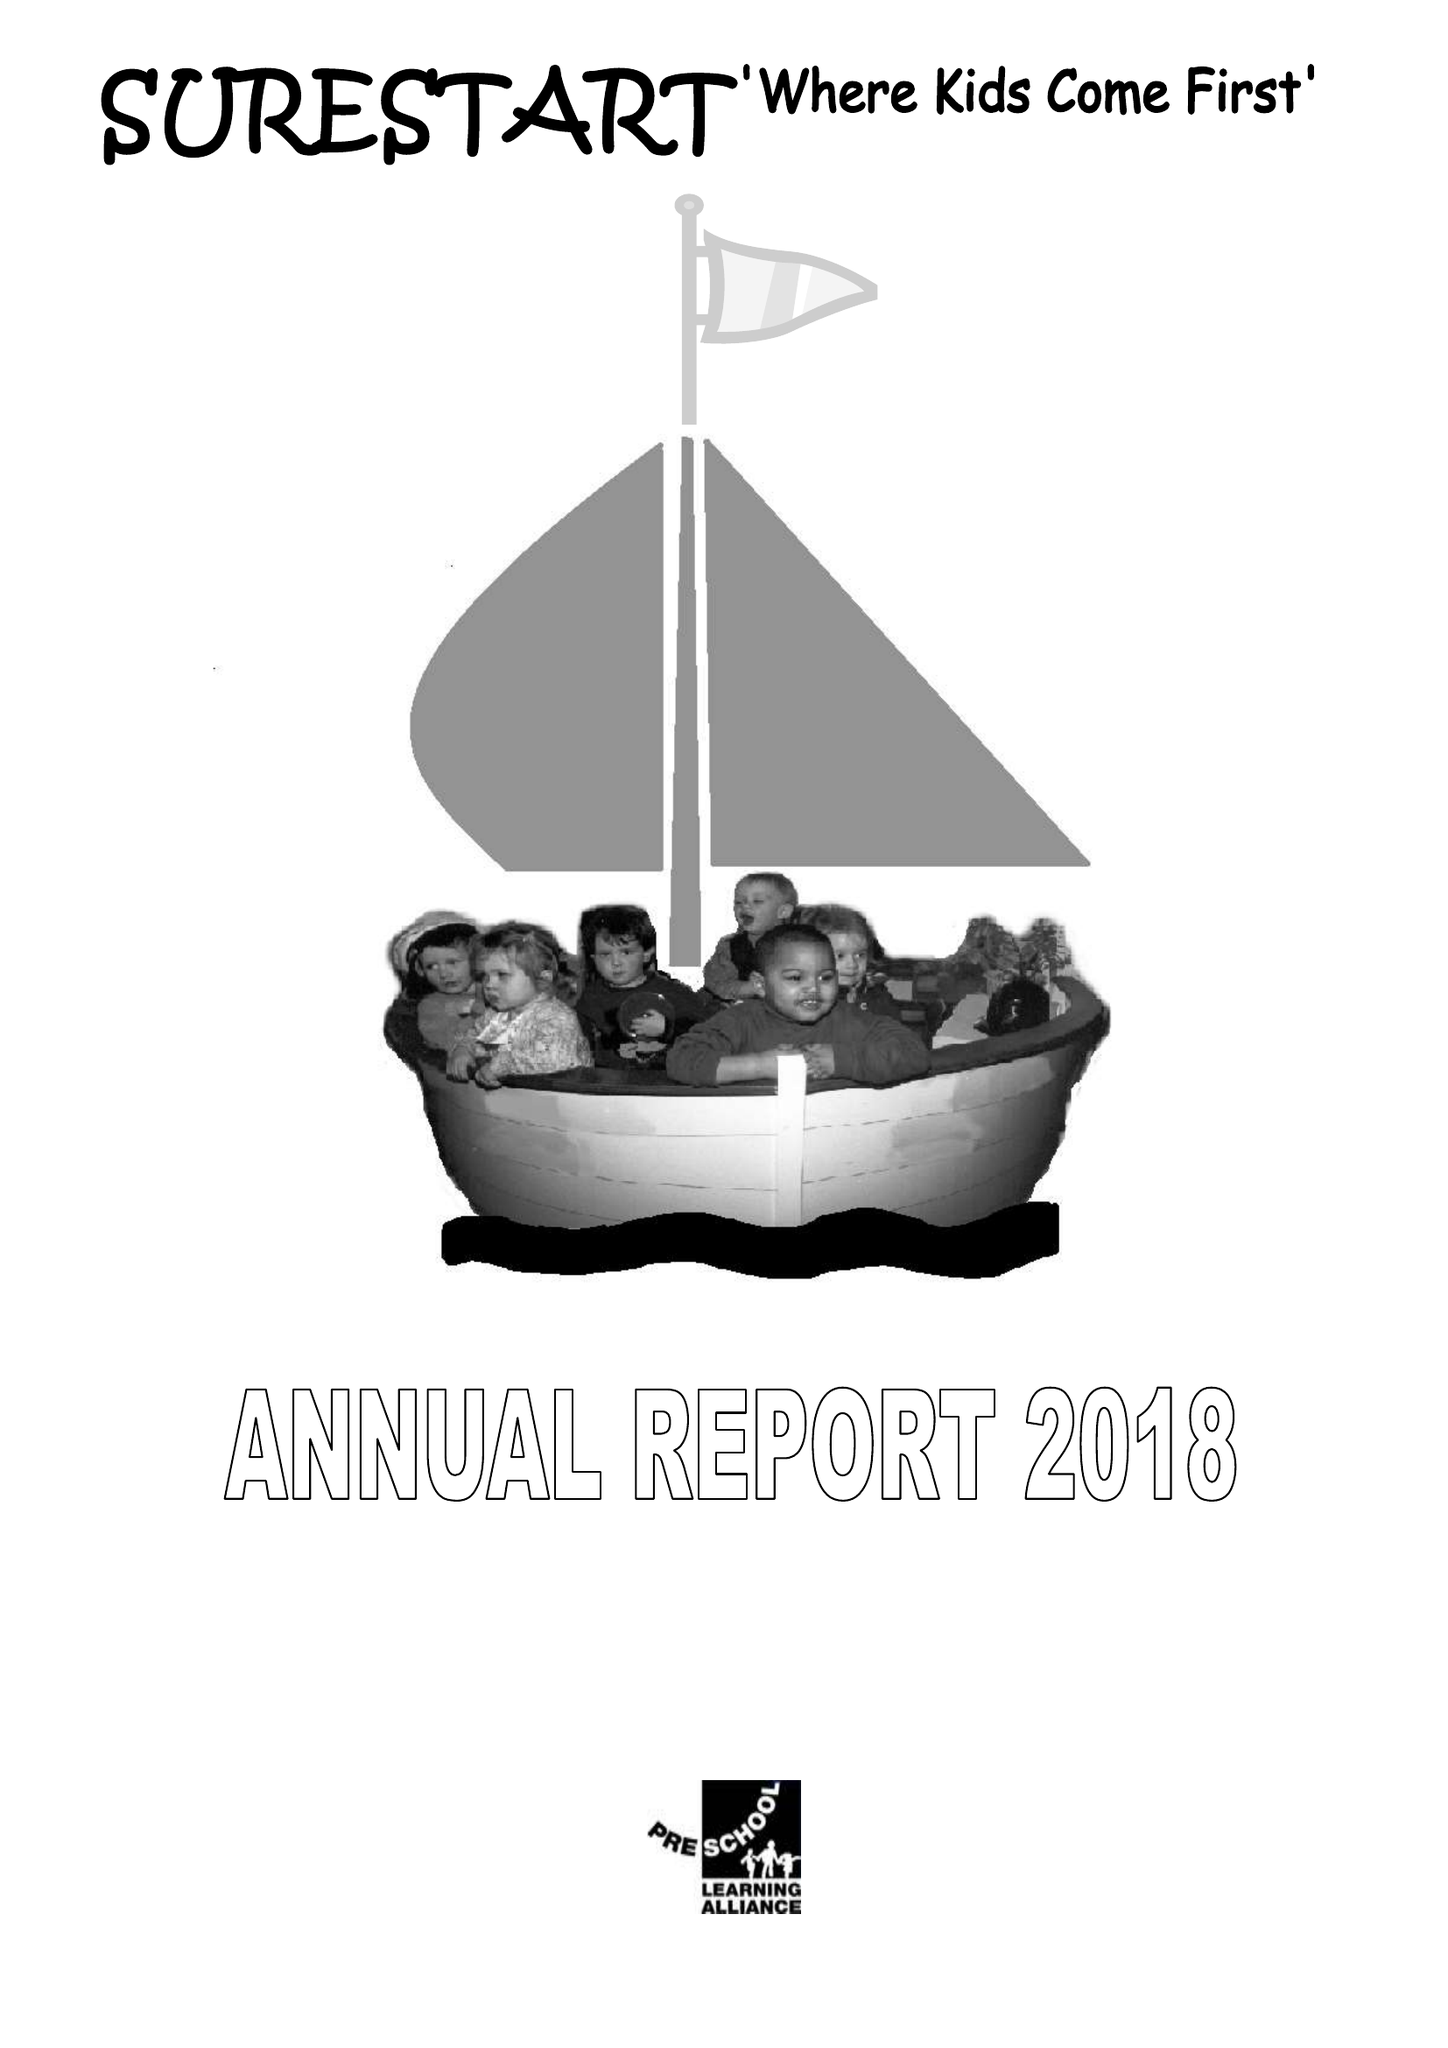What is the value for the charity_name?
Answer the question using a single word or phrase. Surestart 